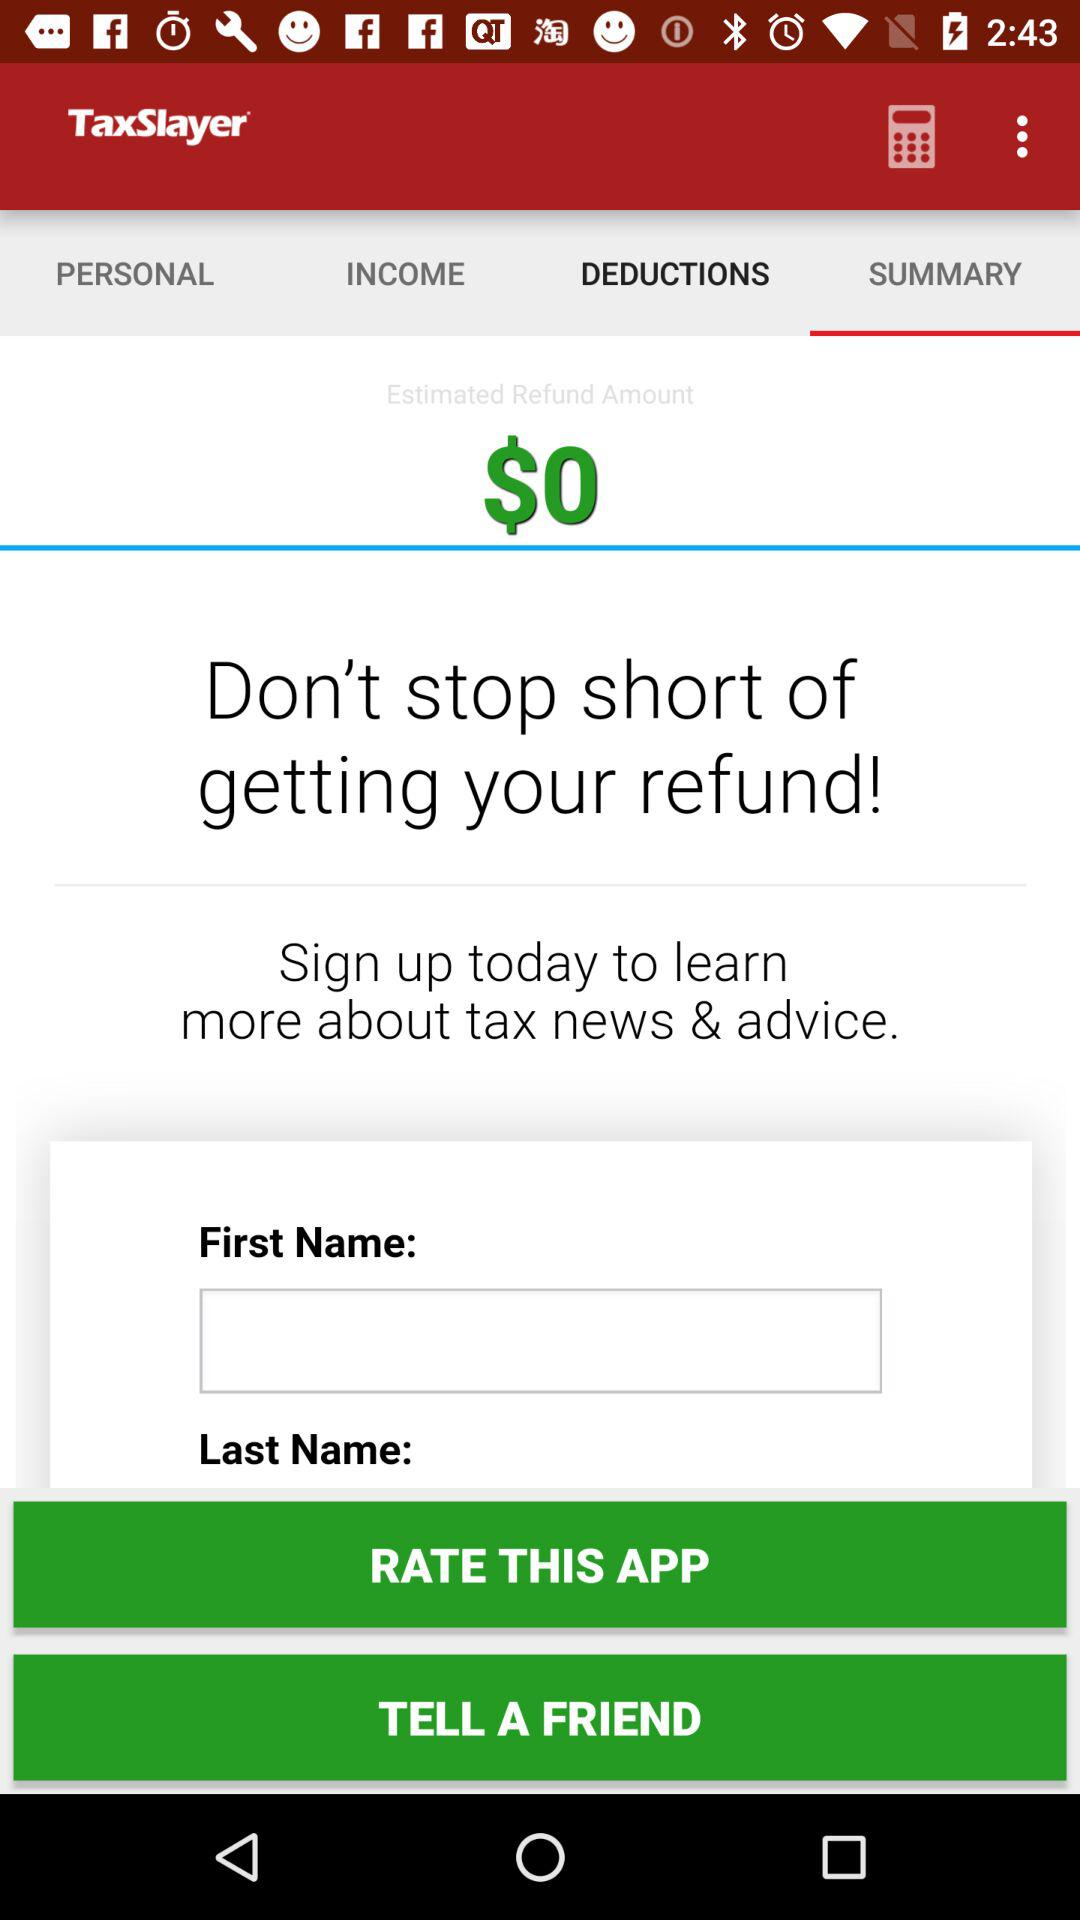What is the current refund amount?
Answer the question using a single word or phrase. $0 